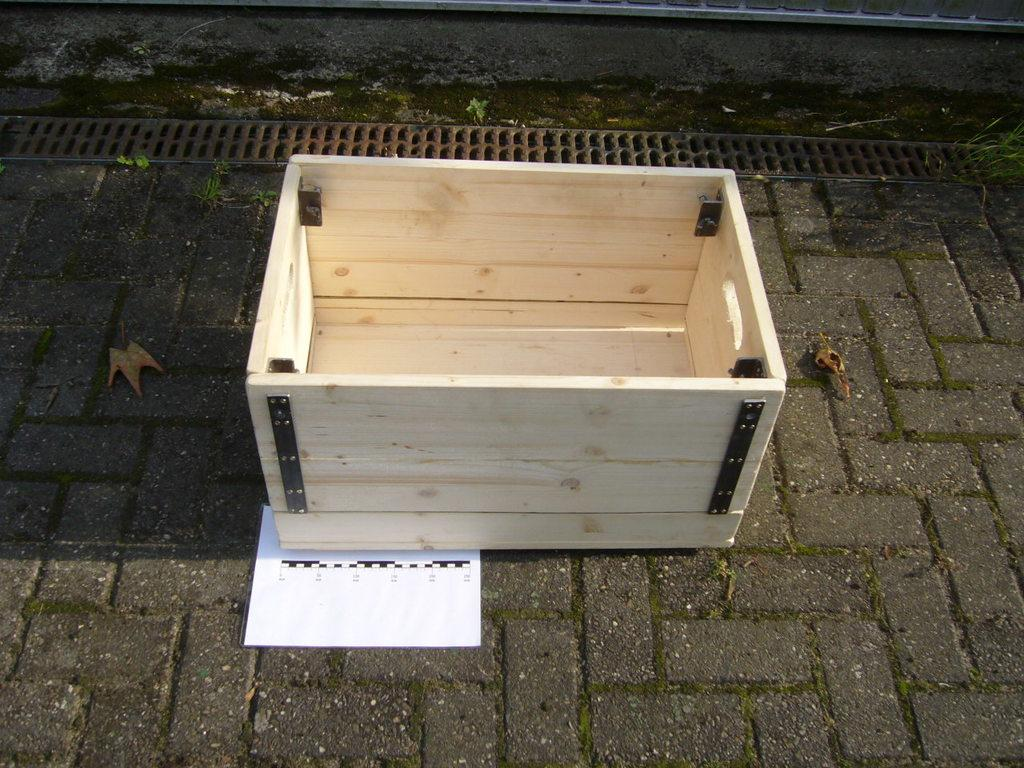What object can be seen in the image that is made of wood? There is a wooden box in the image. Where is the wooden box located? The wooden box is on the side of the road. What type of vegetable is being said good-bye to in the image? There is no vegetable or good-bye being depicted in the image; it only features a wooden box on the side of the road. 